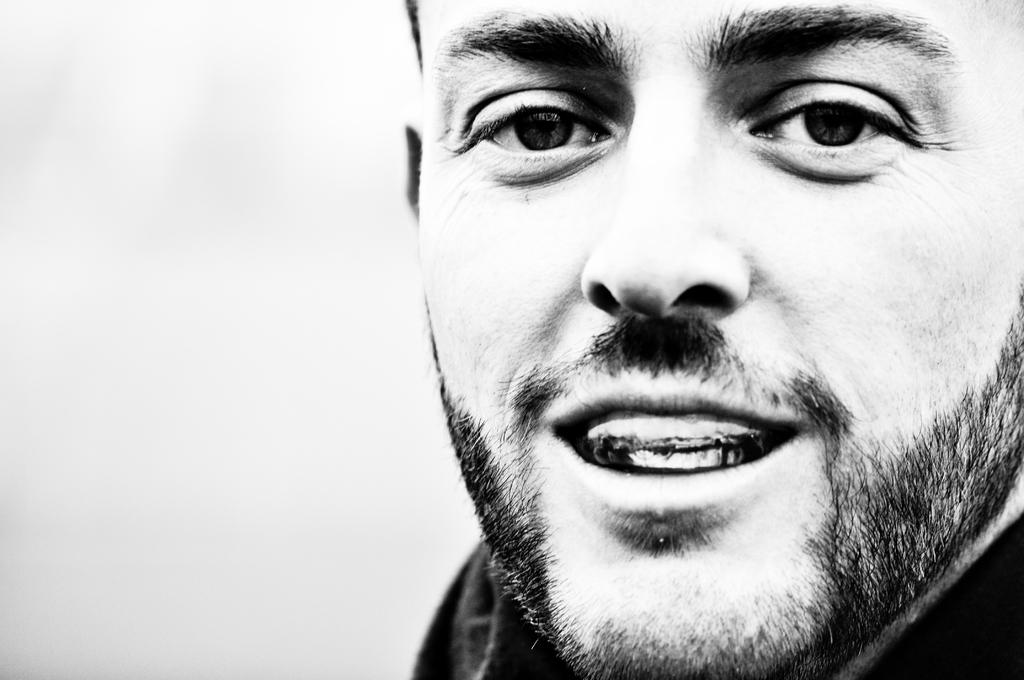What is the color scheme of the image? The image is black and white. What is the main subject of the image? There is a face of a man in the image. What type of collar is the man wearing in the image? There is no collar visible in the image, as it is black and white and only shows the face of a man. 